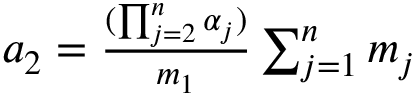Convert formula to latex. <formula><loc_0><loc_0><loc_500><loc_500>\begin{array} { r } { a _ { 2 } = \frac { ( \prod _ { j = 2 } ^ { n } \alpha _ { j } ) } { m _ { 1 } } \sum _ { j = 1 } ^ { n } m _ { j } } \end{array}</formula> 